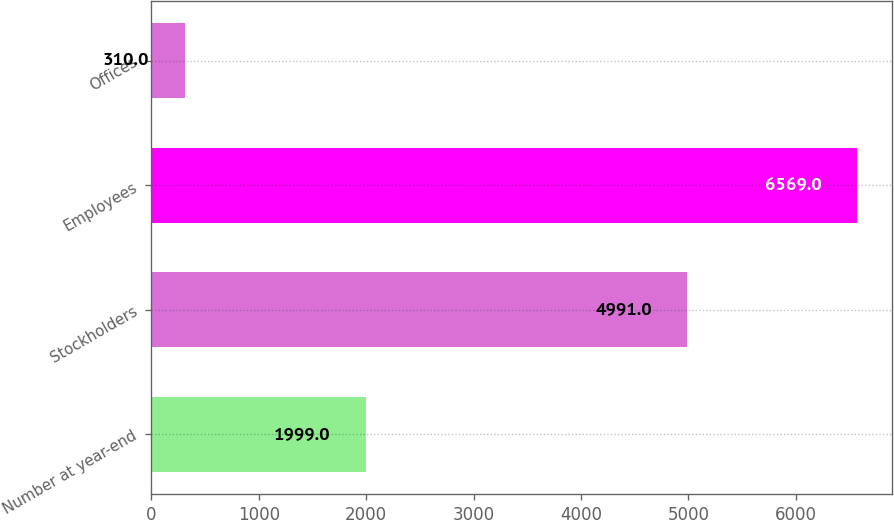<chart> <loc_0><loc_0><loc_500><loc_500><bar_chart><fcel>Number at year-end<fcel>Stockholders<fcel>Employees<fcel>Offices<nl><fcel>1999<fcel>4991<fcel>6569<fcel>310<nl></chart> 